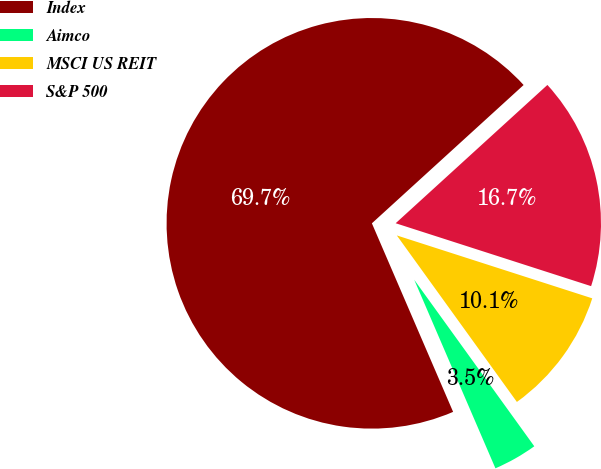<chart> <loc_0><loc_0><loc_500><loc_500><pie_chart><fcel>Index<fcel>Aimco<fcel>MSCI US REIT<fcel>S&P 500<nl><fcel>69.71%<fcel>3.47%<fcel>10.1%<fcel>16.72%<nl></chart> 